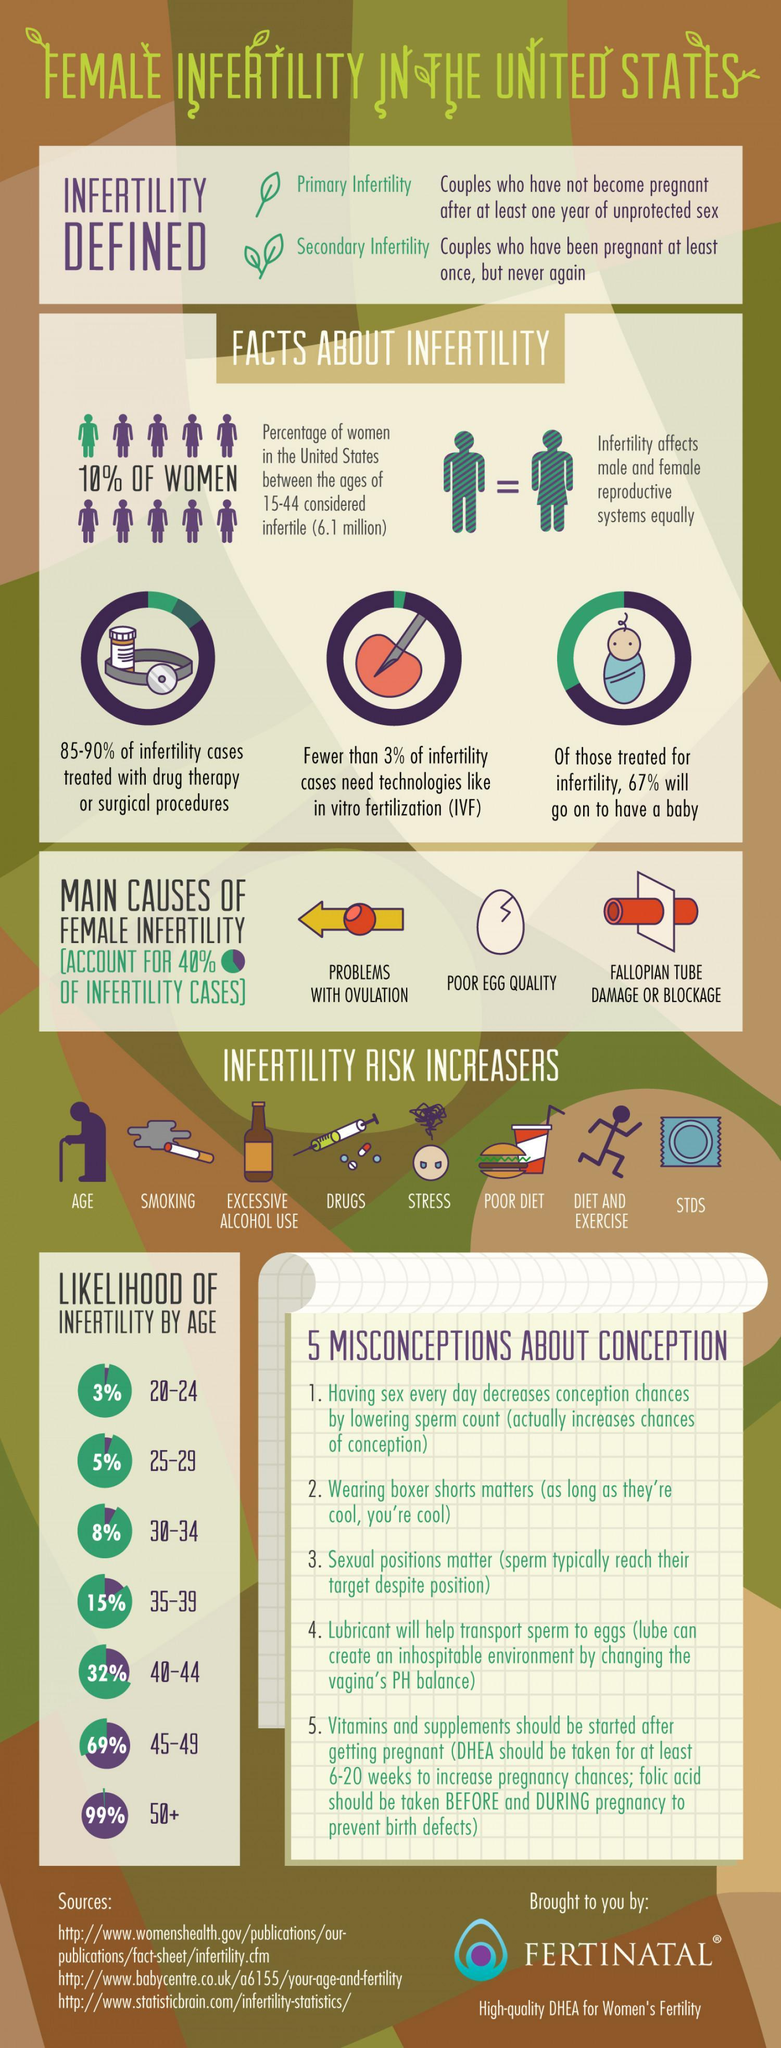What percentage of infertiIity cases in the U.S. need technoIogies Iike IVF?
Answer the question with a short phrase. Fewer than 3% Which age group in femaIes is considered as Ieast fertiIe in the U.S.? 50+ What is the infertiIe femaIe popuIation in the age group of 15-44 in U.S.? 6.1 miIIion What percentage of infertiIe femaIes in the U.S had a baby after infertiIity treatments? 67% What are the two stages of infertility in females? Primary Infertility, Secondary Infertility What percentage is the IikeIihood of infertiIity in the age group of 30-34 in U.S? 8% Which age group in femaIes is considered as the most fertiIe in the U.S.? 20-24 What percentage of women in the U.S. between the ages of 15-44 are considered fertiIe? 90% What percentage of femaIe infertiIity is caused by poor egg quaIity? 40% 